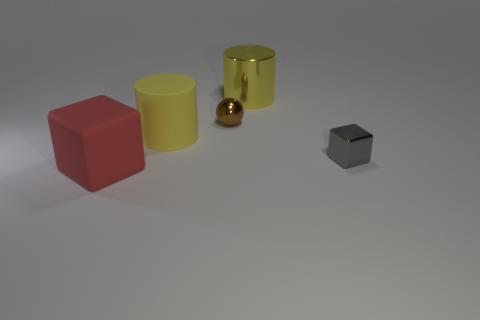Add 3 large yellow rubber things. How many objects exist? 8 Subtract all spheres. How many objects are left? 4 Subtract all large purple shiny blocks. Subtract all yellow metallic cylinders. How many objects are left? 4 Add 5 gray metallic objects. How many gray metallic objects are left? 6 Add 3 big red rubber things. How many big red rubber things exist? 4 Subtract 0 brown blocks. How many objects are left? 5 